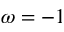Convert formula to latex. <formula><loc_0><loc_0><loc_500><loc_500>\omega = - 1</formula> 